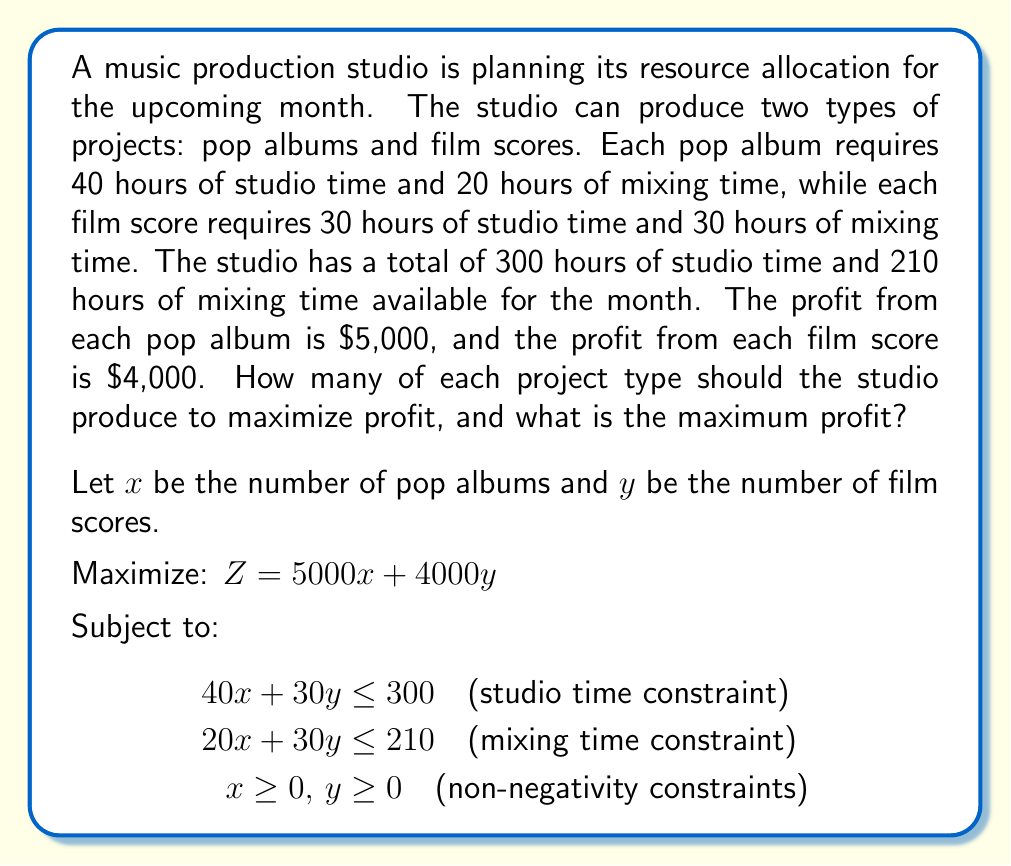Show me your answer to this math problem. To solve this linear programming problem, we'll use the graphical method:

1. Plot the constraints:
   - Studio time: $40x + 30y = 300$
   - Mixing time: $20x + 30y = 210$

2. Identify the feasible region:
   The feasible region is the area that satisfies all constraints, including non-negativity.

3. Find the corner points of the feasible region:
   - (0, 0)
   - (0, 7) (intersection of y-axis and mixing time constraint)
   - (7.5, 0) (intersection of x-axis and studio time constraint)
   - Intersection of studio and mixing time constraints:
     Solve the system of equations:
     $40x + 30y = 300$
     $20x + 30y = 210$
     Subtracting the second equation from the first:
     $20x = 90$
     $x = 4.5$
     Substituting back:
     $20(4.5) + 30y = 210$
     $90 + 30y = 210$
     $30y = 120$
     $y = 4$
     So, the intersection point is (4.5, 4)

4. Evaluate the objective function at each corner point:
   - (0, 0): $Z = 5000(0) + 4000(0) = 0$
   - (0, 7): $Z = 5000(0) + 4000(7) = 28,000$
   - (7.5, 0): $Z = 5000(7.5) + 4000(0) = 37,500$
   - (4.5, 4): $Z = 5000(4.5) + 4000(4) = 38,500$

5. The maximum profit occurs at the point (4.5, 4).

However, since we can't produce fractional projects, we need to check the nearest integer solutions:
   - (4, 4): $Z = 5000(4) + 4000(4) = 36,000$
   - (5, 3): $Z = 5000(5) + 4000(3) = 37,000$

Therefore, the optimal integer solution is to produce 5 pop albums and 3 film scores.
Answer: The studio should produce 5 pop albums and 3 film scores to maximize profit. The maximum profit is $37,000. 